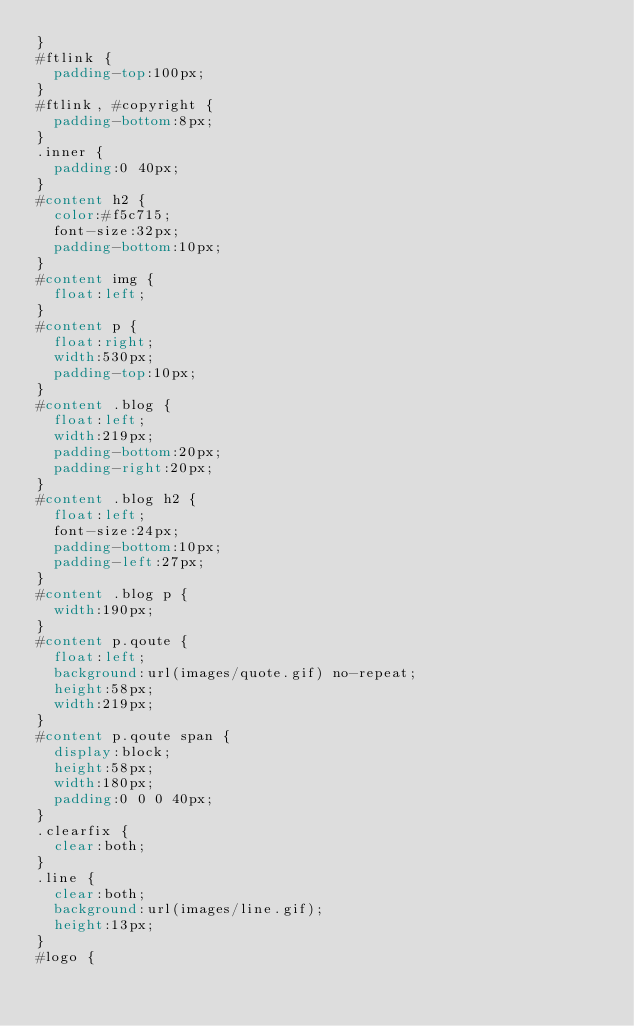<code> <loc_0><loc_0><loc_500><loc_500><_CSS_>}
#ftlink {
	padding-top:100px;
}
#ftlink, #copyright {
	padding-bottom:8px;
}
.inner {
	padding:0 40px;
}
#content h2 {
	color:#f5c715;
	font-size:32px;
	padding-bottom:10px;
}
#content img {
	float:left;
}
#content p {
	float:right;
	width:530px;
	padding-top:10px;
}
#content .blog {
	float:left;
	width:219px;
	padding-bottom:20px;
	padding-right:20px;
}
#content .blog h2 {
	float:left;
	font-size:24px;
	padding-bottom:10px;
	padding-left:27px;
}
#content .blog p {
	width:190px;
}
#content p.qoute {
	float:left;
	background:url(images/quote.gif) no-repeat;
	height:58px;
	width:219px;
}
#content p.qoute span {
	display:block;
	height:58px;
	width:180px;
	padding:0 0 0 40px;
}
.clearfix {
	clear:both;
}
.line {
	clear:both;
	background:url(images/line.gif);
	height:13px;
}
#logo {</code> 